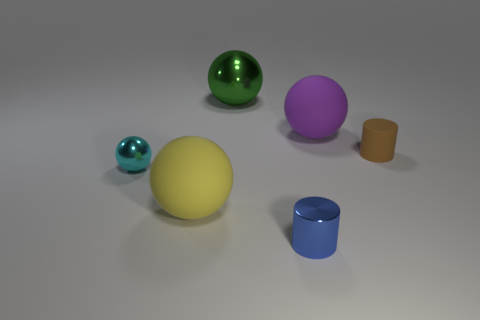Subtract all big spheres. How many spheres are left? 1 Subtract all yellow balls. How many balls are left? 3 Add 2 tiny purple cylinders. How many objects exist? 8 Subtract 2 balls. How many balls are left? 2 Subtract all spheres. How many objects are left? 2 Subtract all brown spheres. How many cyan cylinders are left? 0 Subtract all blue cylinders. Subtract all big yellow rubber things. How many objects are left? 4 Add 5 tiny spheres. How many tiny spheres are left? 6 Add 1 large blue shiny balls. How many large blue shiny balls exist? 1 Subtract 0 green blocks. How many objects are left? 6 